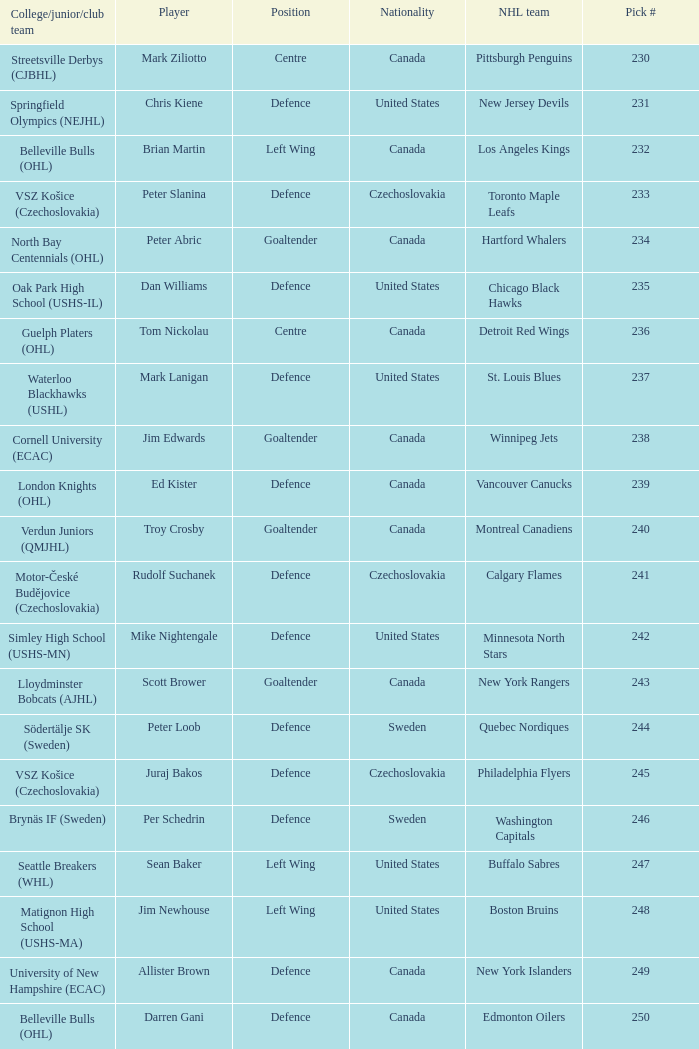List the players for team brynäs if (sweden). Per Schedrin. 